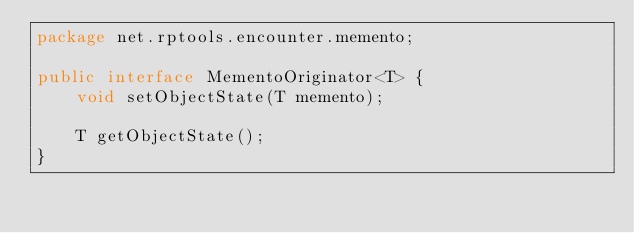<code> <loc_0><loc_0><loc_500><loc_500><_Java_>package net.rptools.encounter.memento;

public interface MementoOriginator<T> {
    void setObjectState(T memento);

    T getObjectState();
}
</code> 